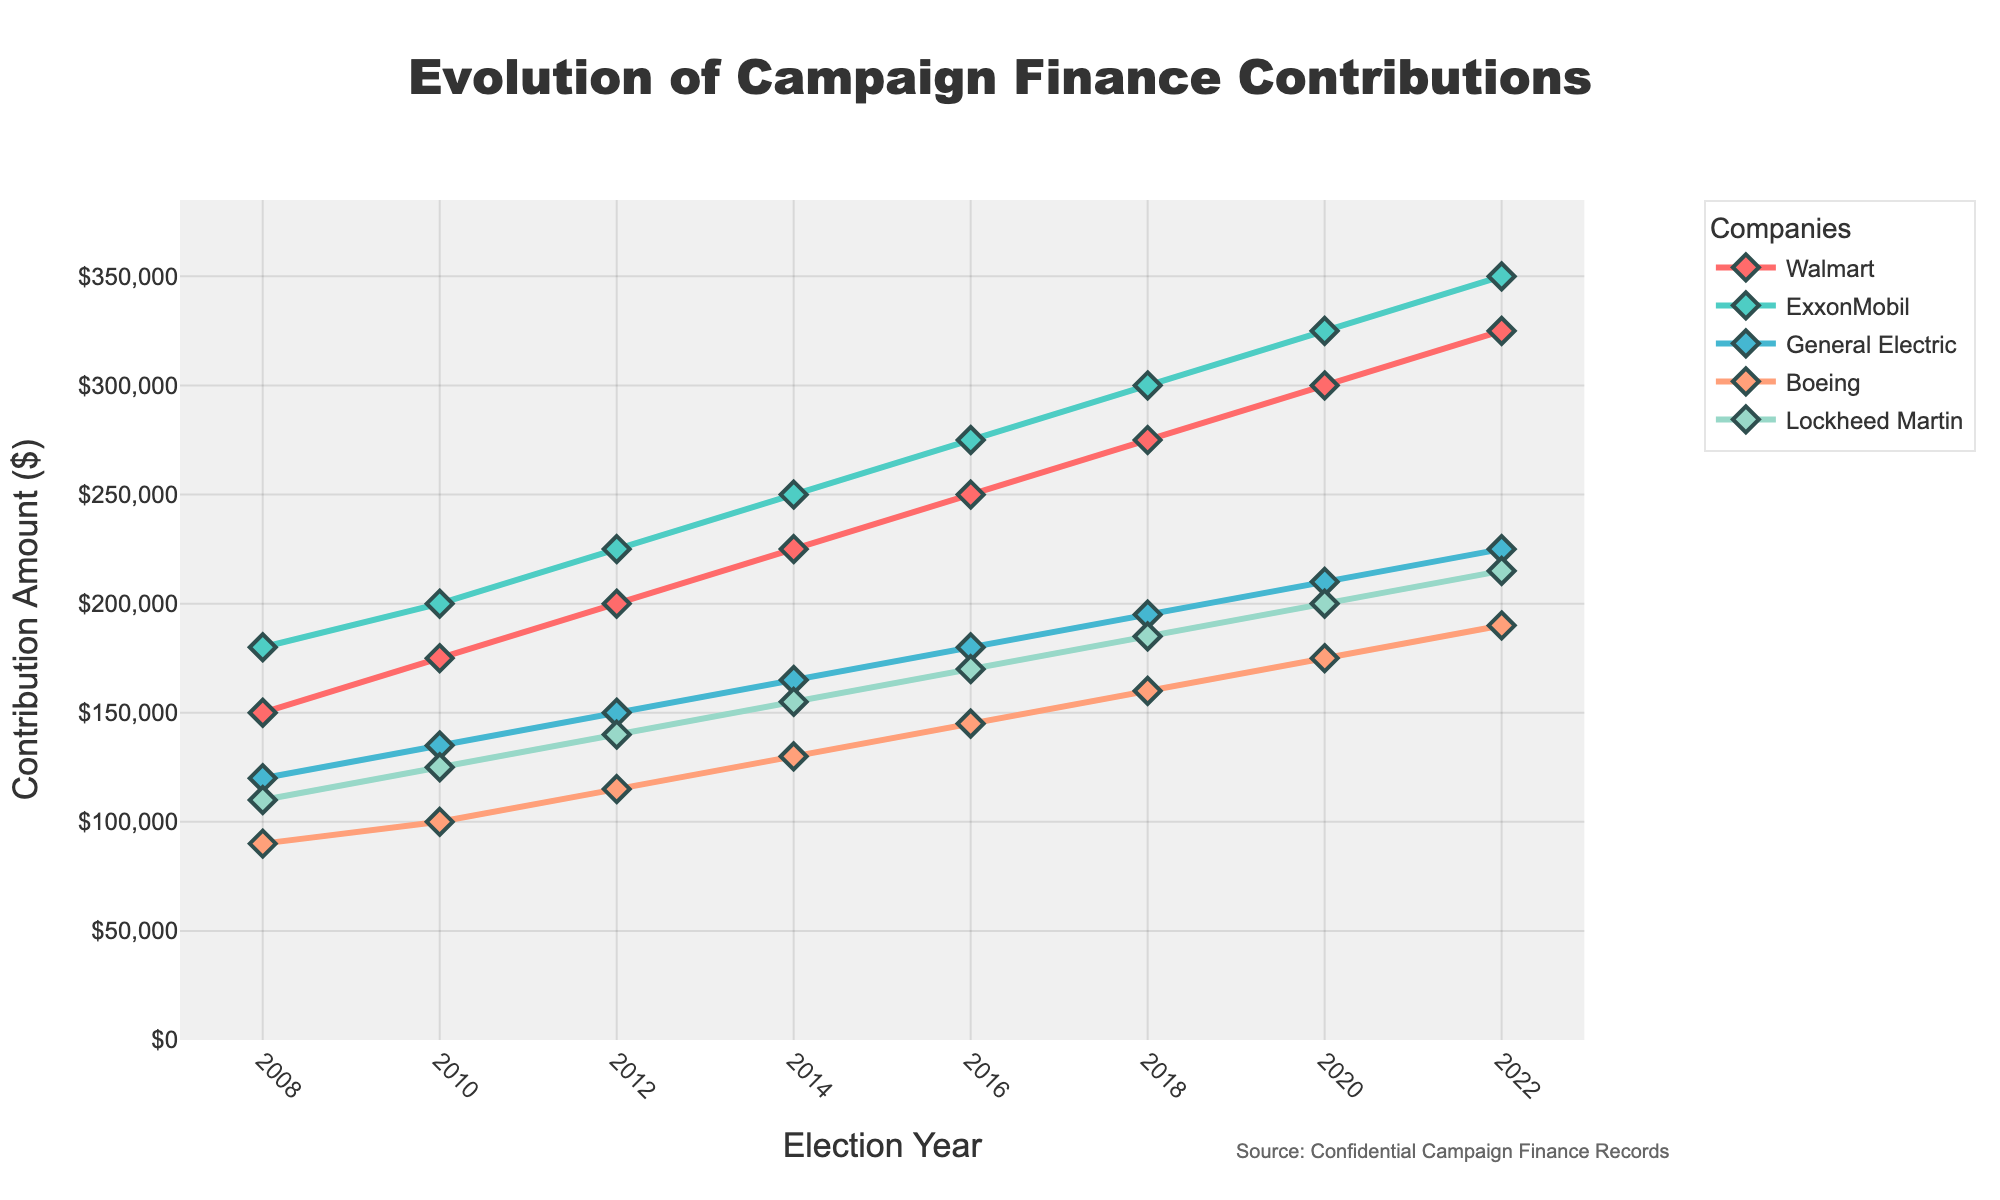What's the average campaign contribution by General Electric from 2008 to 2022? Add all contributions by General Electric over the given years: 120000 + 135000 + 150000 + 165000 + 180000 + 195000 + 210000 + 225000 = 1385000. Divide by the number of years: 1385000 / 8 = 173125
Answer: 173125 Which company had the highest contribution in 2022? Look at the 2022 values for all companies: Walmart = 325000, ExxonMobil = 350000, General Electric = 225000, Boeing = 190000, Lockheed Martin = 215000. ExxonMobil has the highest value at 350000
Answer: ExxonMobil Did any company's contribution decrease in any election cycle? Check if any company's value decreased from one year to the next: All companies show an increasing trend in contributions over the years. No company had a decrease in contributions.
Answer: No What is the difference in contributions between Walmart and Boeing in 2016? Subtract Boeing's 2016 contribution from Walmart's 2016 contribution: 250000 - 145000 = 105000
Answer: 105000 By how much did Lockheed Martin's contributions increase from 2010 to 2020? Subtract Lockheed Martin's 2010 contribution from its 2020 contribution: 200000 - 125000 = 75000
Answer: 75000 What year saw Boeing's contributions surpass 150,000 for the first time? Track Boeing's contributions over the years: 2008 = 90000, 2010 = 100000, 2012 = 115000, 2014 = 130000, 2016 = 145000, 2018 = 160000. The contribution first surpasses 150,000 in 2018.
Answer: 2018 Which company had the least cumulative contribution from 2008 to 2022? Calculate the cumulative sum for all companies and compare: Walmart = 2000000, ExxonMobil = 2350000, General Electric = 1385000, Boeing = 1115000, Lockheed Martin = 1300000. Boeing has the least cumulative sum.
Answer: Boeing What is the combined contribution of ExxonMobil and Lockheed Martin in 2014? Add the contributions of ExxonMobil and Lockheed Martin in 2014: 250000 + 155000 = 405000
Answer: 405000 Compare the rate of increase in contributions for Walmart and General Electric from 2008 to 2022. Which company had a higher rate of increase? Examine the contributions increase: Walmart's 2008 contribution was 150000 and 2022 was 325000, increase = 175000. General Electric's 2008 contribution was 120000 and 2022 was 225000, increase = 105000. Walmart had a higher rate of increase.
Answer: Walmart What was the trend in campaign contributions by Boeing from 2010 to 2020? Analyze Boeing's contributions over the relevant years: 2010 = 100000, 2012 = 115000, 2014 = 130000, 2016 = 145000, 2018 = 160000, 2020 = 175000. The contributions exhibit a consistently increasing trend.
Answer: Increasing 